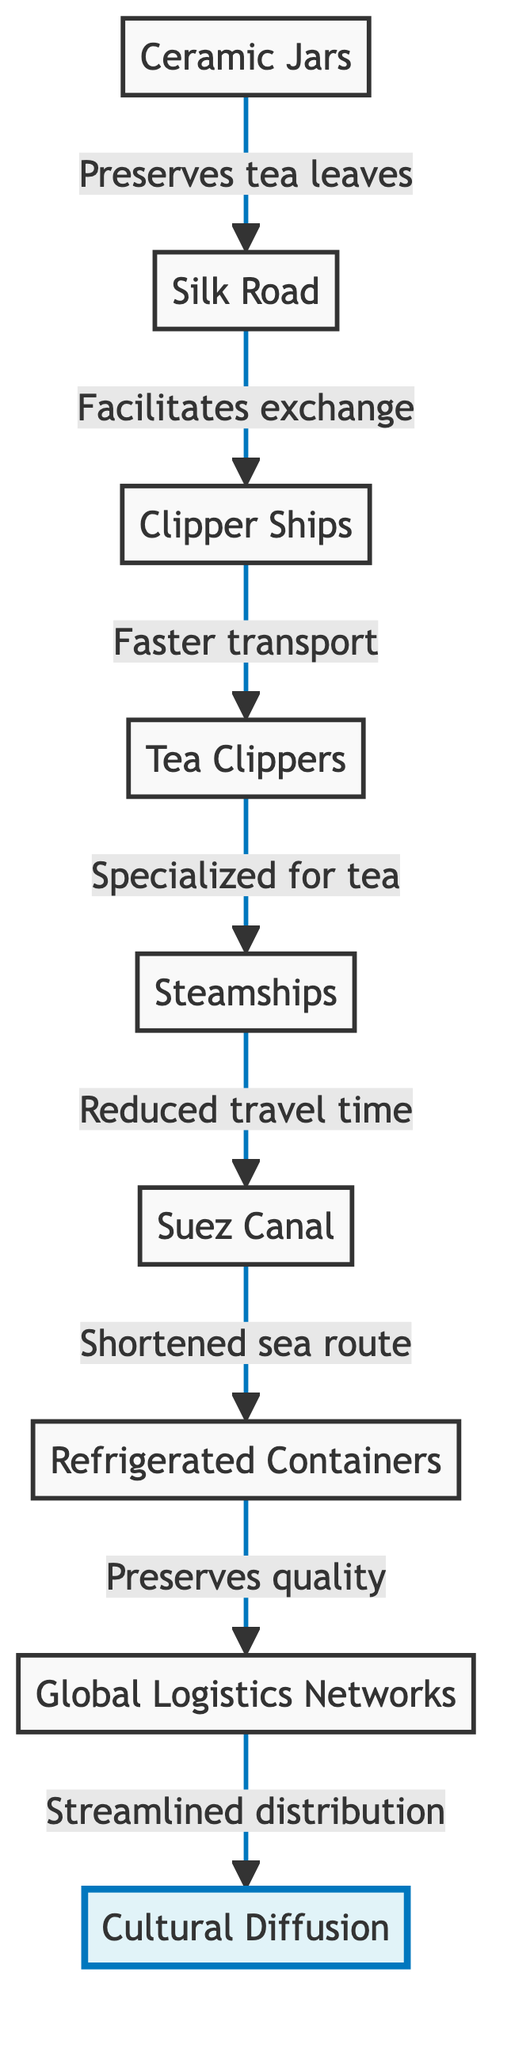What is the first element in the diagram? The first element in the diagram is "Ceramic Jars," which is at the bottom and denotes the starting point of the flow.
Answer: Ceramic Jars How many nodes are in the diagram? The diagram contains nine nodes, which include all the key innovations in tea transport and their outcomes listed.
Answer: 9 What connection does "Clipper Ships" have with the "Suez Canal"? The connection denotes that "Clipper Ships," which allowed for faster transport, eventually led to the development of the "Suez Canal," further facilitating tea trade routes by shortening sea travel.
Answer: Faster transport What is the relationship between "Refrigerated Containers" and "Cultural Diffusion"? The relationship shows that the use of "Refrigerated Containers" ensured the preservation of tea quality during transport, which contributed to an increase in global distribution and ultimately led to "Cultural Diffusion."
Answer: Preserves quality Which innovation directly follows "Steamships" in the flow? The innovation that directly follows "Steamships" in the flow is the "Suez Canal," indicating that steamship advancements in transport efficiency led to the construction of the canal for trade benefits.
Answer: Suez Canal What type of ships were specifically designed for transporting tea? The ships specifically designed for transporting tea are called "Tea Clippers," which are a specialized type of "Clipper Ships."
Answer: Tea Clippers What was the impact of the "Suez Canal" on tea trade routes? The "Suez Canal" had a significant impact as it dramatically shortened the sea route for tea trade between Asia and Europe, making transportation more efficient.
Answer: Shortened sea route What is the primary outcome of the entire process in the diagram? The primary outcome of the entire process depicted in the diagram is "Cultural Diffusion," showcasing how innovations in tea transport led to the worldwide spread of tea-related practices.
Answer: Cultural Diffusion What role do "Global Logistics Networks" play in the diagram? "Global Logistics Networks" streamline the distribution of tea, indicating the modern advancements in logistics that facilitate global tea trade and distribution.
Answer: Streamlined distribution 